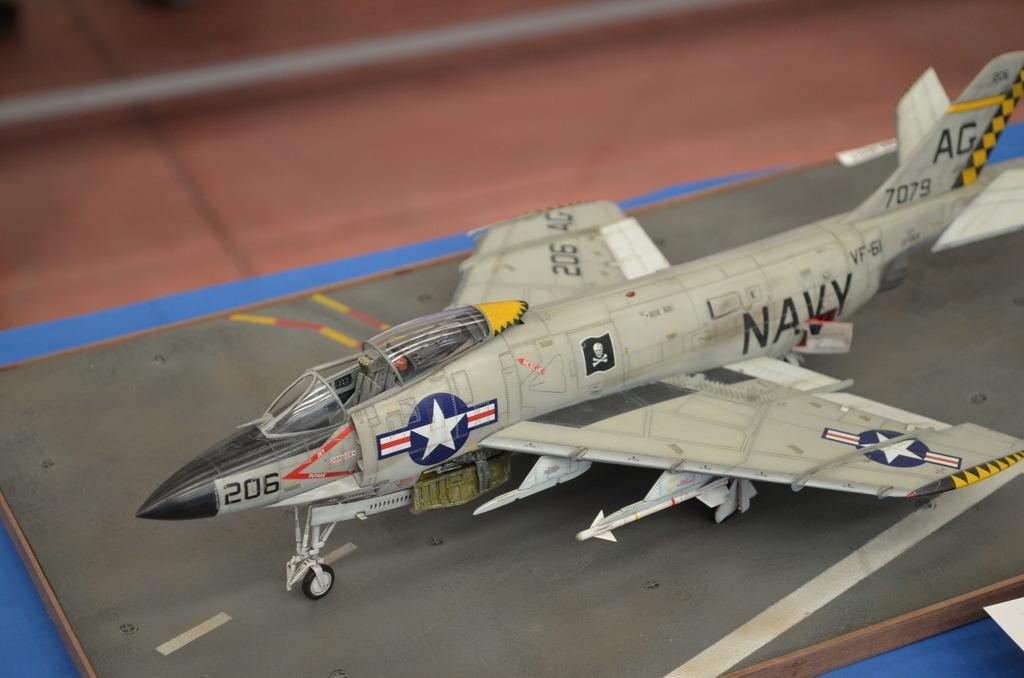Provide a one-sentence caption for the provided image. a model us navy airplaine sitting on the counter. 